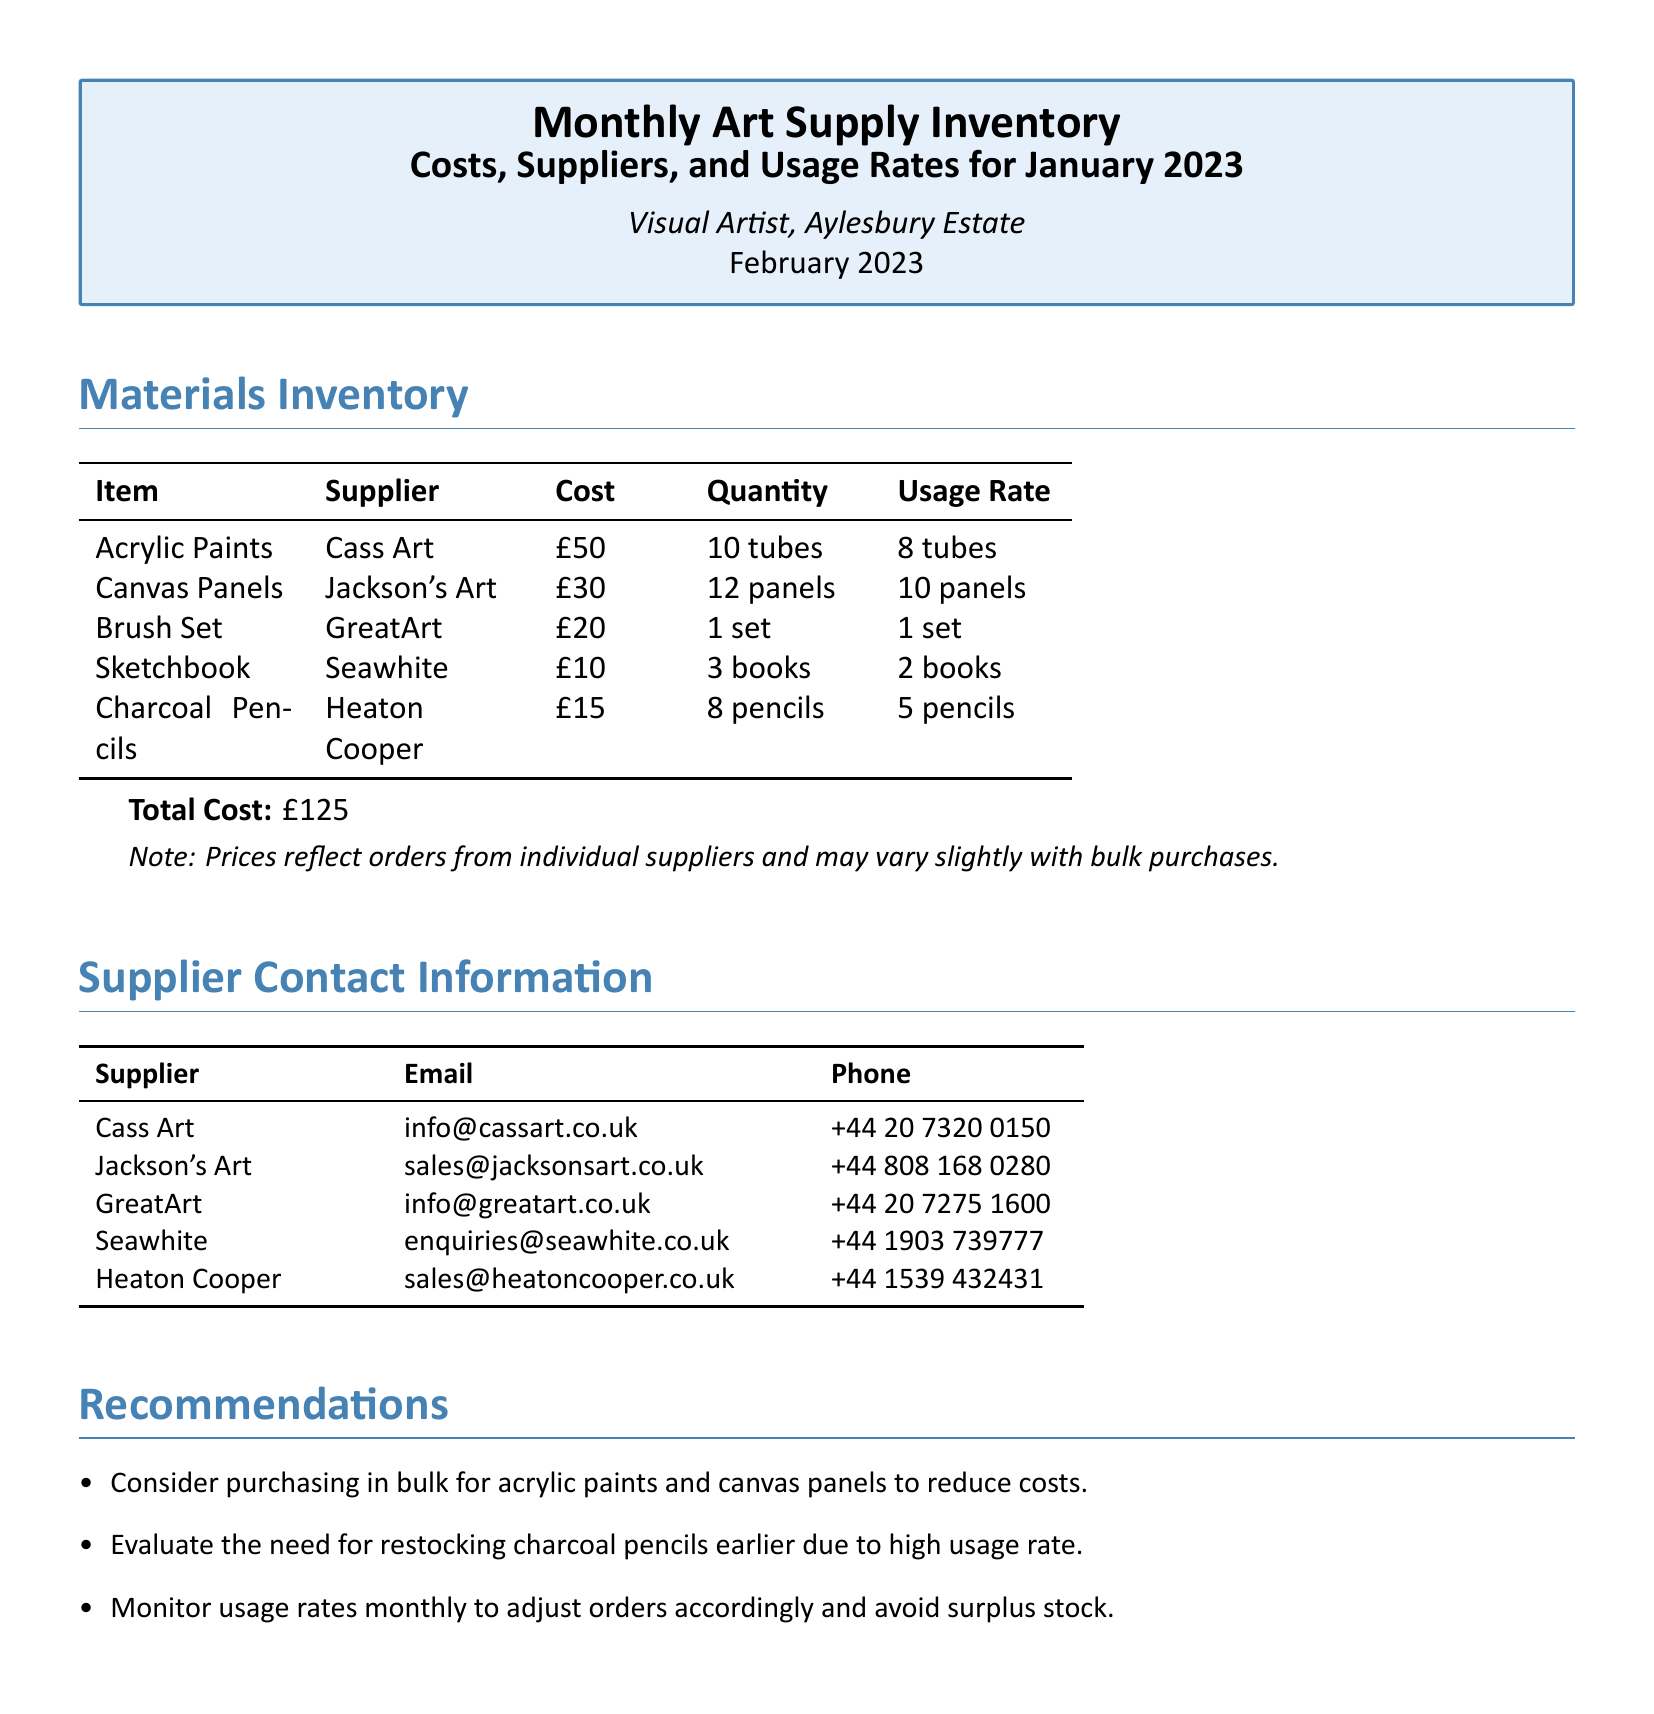what is the total cost of art supplies? The total cost is summarized at the end of the materials inventory section of the document.
Answer: £125 who is the supplier for acrylic paints? The supplier's name is listed next to the item in the materials inventory.
Answer: Cass Art how many tubes of acrylic paints were used? The usage rate is specified in the inventory for each item, including acrylic paints.
Answer: 8 tubes what is the recommended action for charcoal pencils? The recommendations section discusses actions based on usage rates, specifically for charcoal pencils.
Answer: Restock earlier how many canvas panels were purchased? The quantity for each item is detailed in the inventory table.
Answer: 12 panels which supplier provides sketchbooks? The supplier associated with the sketchbooks is indicated in the inventory.
Answer: Seawhite what is the usage rate for brush sets? The usage rate is presented in the inventory table under the respective item.
Answer: 1 set how many suppliers are listed in the document? The number of suppliers is counted from the supplier contact information section.
Answer: 5 suppliers what is the email address for GreatArt? The email for each supplier is provided in the contact information section.
Answer: info@greatart.co.uk 